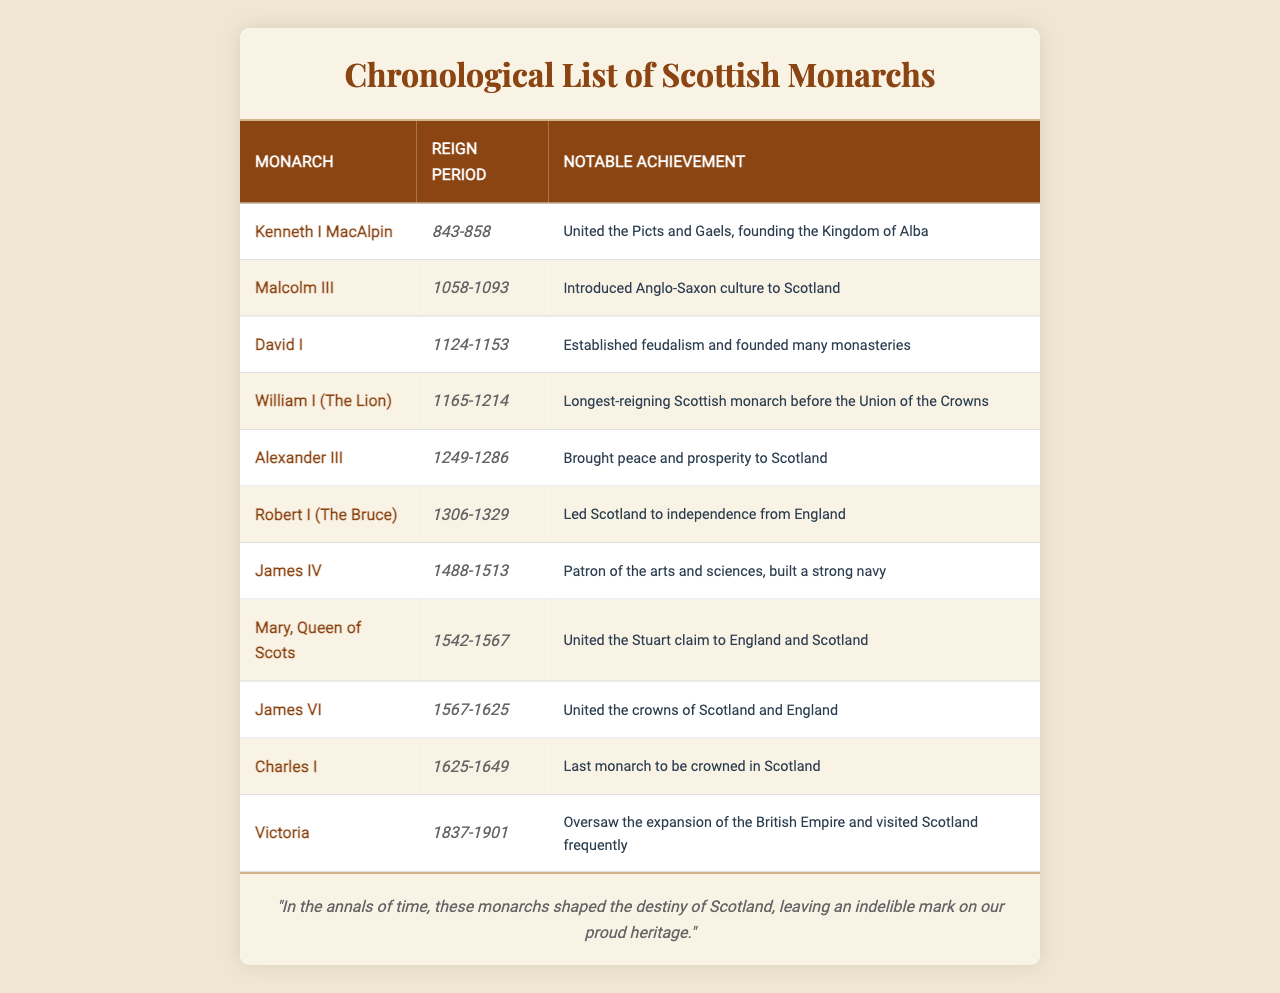What was the reign period of Robert I (The Bruce)? In the table, Robert I (The Bruce) is listed with the reign period from 1306 to 1329.
Answer: 1306-1329 Who is noted for uniting the Picts and Gaels? The table indicates that Kenneth I MacAlpin united the Picts and Gaels, which is highlighted in his notable achievements.
Answer: Kenneth I MacAlpin Which monarch had the longest reign before the Union of the Crowns? According to the table, William I (The Lion) is mentioned as the longest-reigning Scottish monarch before the Union of the Crowns, with the reign period from 1165 to 1214.
Answer: William I (The Lion) How many Scottish monarchs are listed in the table? By counting the entries in the table, there are a total of 11 monarchs listed.
Answer: 11 Was Mary, Queen of Scots, significant for uniting the Stuart claim to England and Scotland? The table confirms that Mary, Queen of Scots, is noted for uniting the Stuart claim to both England and Scotland, affirming her significance in history.
Answer: Yes Which monarch's notable achievement included the establishment of feudalism? The table notes that David I established feudalism as part of his notable achievements during his reign from 1124 to 1153.
Answer: David I What notable achievement is associated with Victoria? From the table, Victoria’s notable achievement includes overseeing the expansion of the British Empire and her frequent visits to Scotland during her reign from 1837 to 1901.
Answer: Expansion of the British Empire How many years did Alexander III reign? Alexander III's reign period was from 1249 to 1286. Calculating the years, 1286 - 1249 = 37 years.
Answer: 37 years Which monarch was the last to be crowned in Scotland? The table lists Charles I as the last monarch to be crowned in Scotland, with his reign from 1625 to 1649.
Answer: Charles I Did any monarch in the table reign during the 19th century? Yes, looking at the reign periods, Victoria reigned from 1837 to 1901, which falls in the 19th century.
Answer: Yes What can you infer about the relationship between the reign periods and the notable achievements of James VI and James IV? James VI (1567-1625) is known for uniting the crowns of Scotland and England, while James IV (1488-1513) is recognized as a patron of the arts and sciences and building a strong navy. This indicates a shift in focus from military and cultural patronage to political unification in Scotland’s history.
Answer: There is a shift from cultural patronage to political unification 